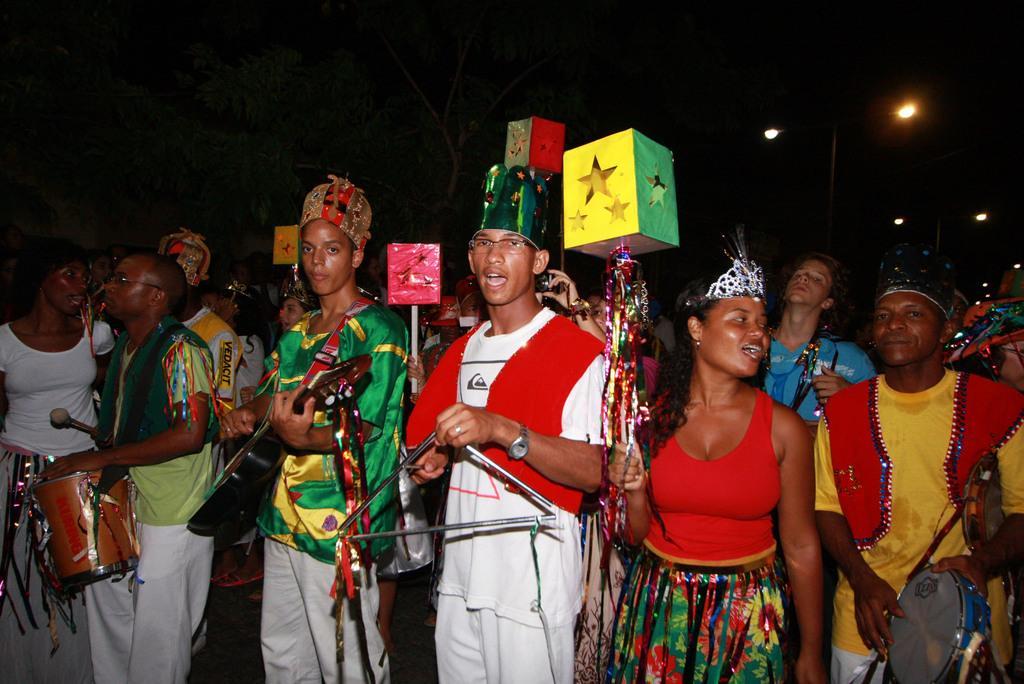Can you describe this image briefly? In this picture there are group of people they are standing at the center of the image, by holding the music instruments like drums, guitars, and tabla, it seems to be they are celebrating and it is the view of the road. 